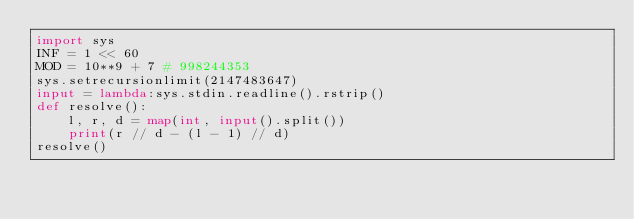<code> <loc_0><loc_0><loc_500><loc_500><_Python_>import sys
INF = 1 << 60
MOD = 10**9 + 7 # 998244353
sys.setrecursionlimit(2147483647)
input = lambda:sys.stdin.readline().rstrip()
def resolve():
    l, r, d = map(int, input().split())
    print(r // d - (l - 1) // d)
resolve()</code> 